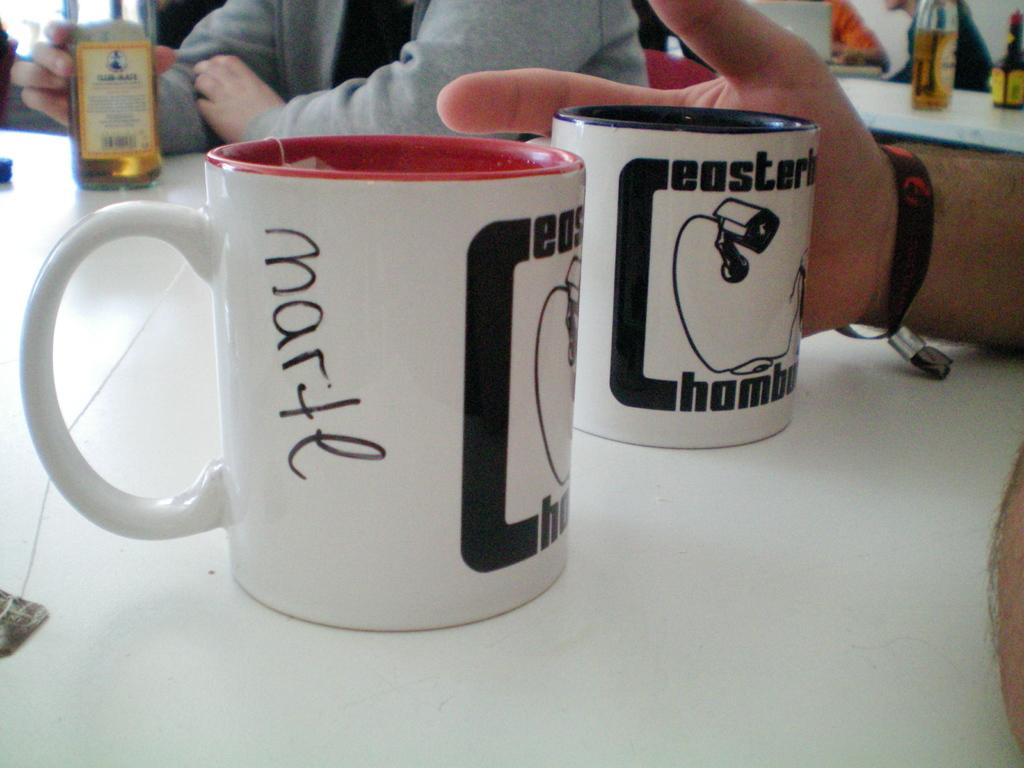<image>
Create a compact narrative representing the image presented. A pair of coffee cups, the closest one has Marte written on it in marker. 